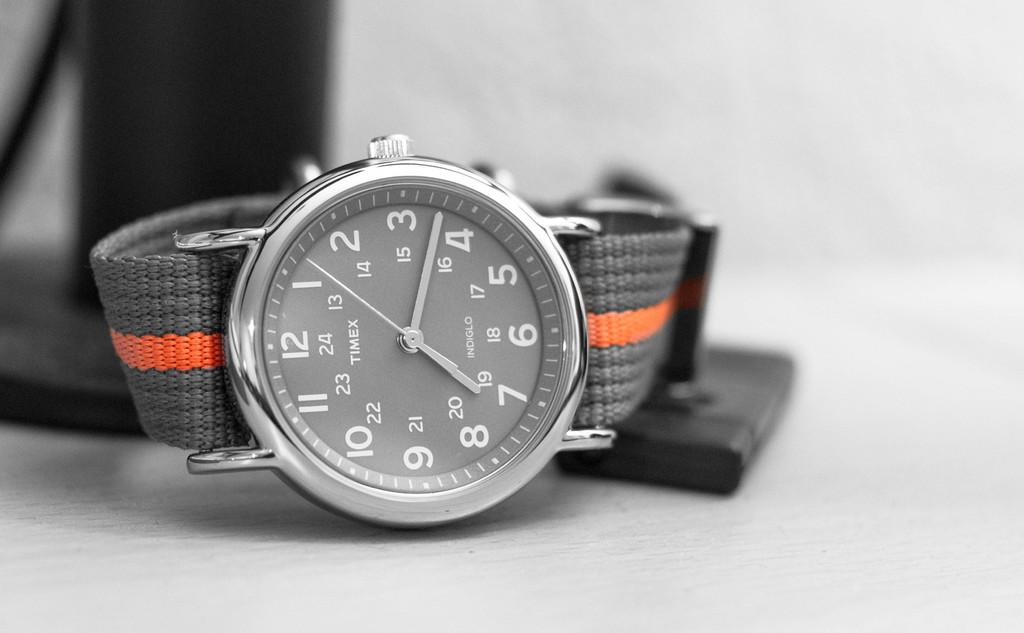<image>
Write a terse but informative summary of the picture. A black and gray watch with a red stripe in the band and says timex on the watch face. 